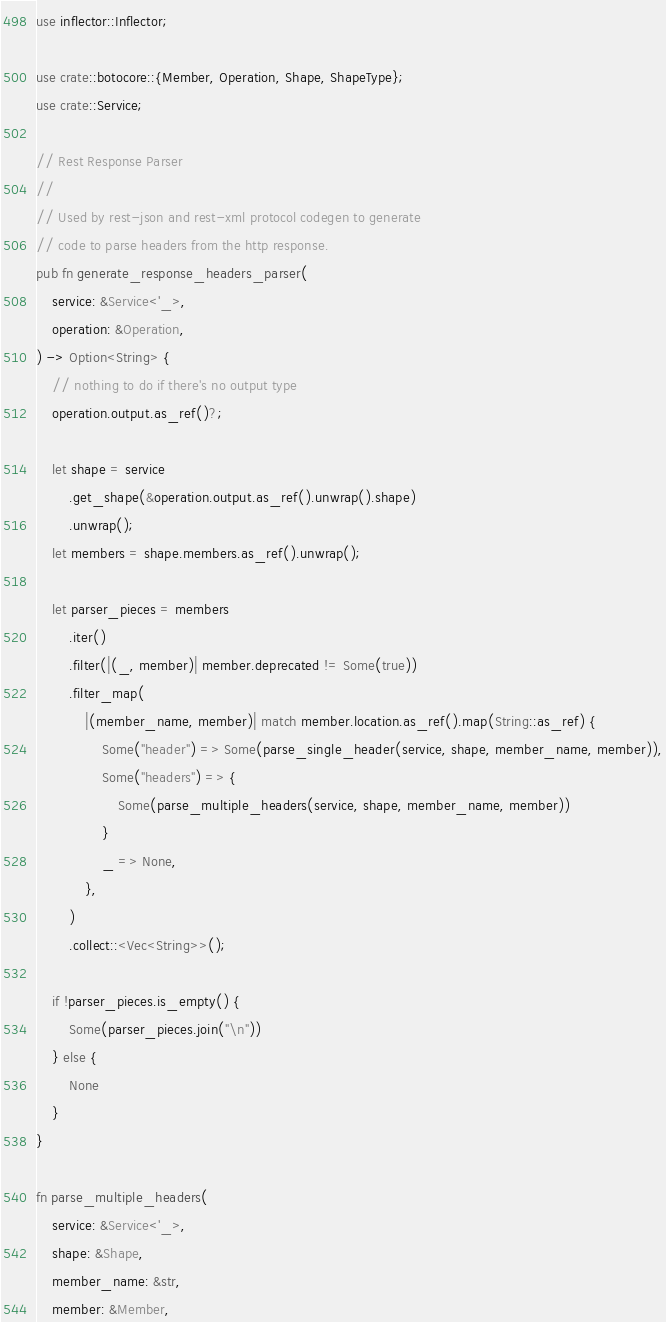<code> <loc_0><loc_0><loc_500><loc_500><_Rust_>use inflector::Inflector;

use crate::botocore::{Member, Operation, Shape, ShapeType};
use crate::Service;

// Rest Response Parser
//
// Used by rest-json and rest-xml protocol codegen to generate
// code to parse headers from the http response.
pub fn generate_response_headers_parser(
    service: &Service<'_>,
    operation: &Operation,
) -> Option<String> {
    // nothing to do if there's no output type
    operation.output.as_ref()?;

    let shape = service
        .get_shape(&operation.output.as_ref().unwrap().shape)
        .unwrap();
    let members = shape.members.as_ref().unwrap();

    let parser_pieces = members
        .iter()
        .filter(|(_, member)| member.deprecated != Some(true))
        .filter_map(
            |(member_name, member)| match member.location.as_ref().map(String::as_ref) {
                Some("header") => Some(parse_single_header(service, shape, member_name, member)),
                Some("headers") => {
                    Some(parse_multiple_headers(service, shape, member_name, member))
                }
                _ => None,
            },
        )
        .collect::<Vec<String>>();

    if !parser_pieces.is_empty() {
        Some(parser_pieces.join("\n"))
    } else {
        None
    }
}

fn parse_multiple_headers(
    service: &Service<'_>,
    shape: &Shape,
    member_name: &str,
    member: &Member,</code> 